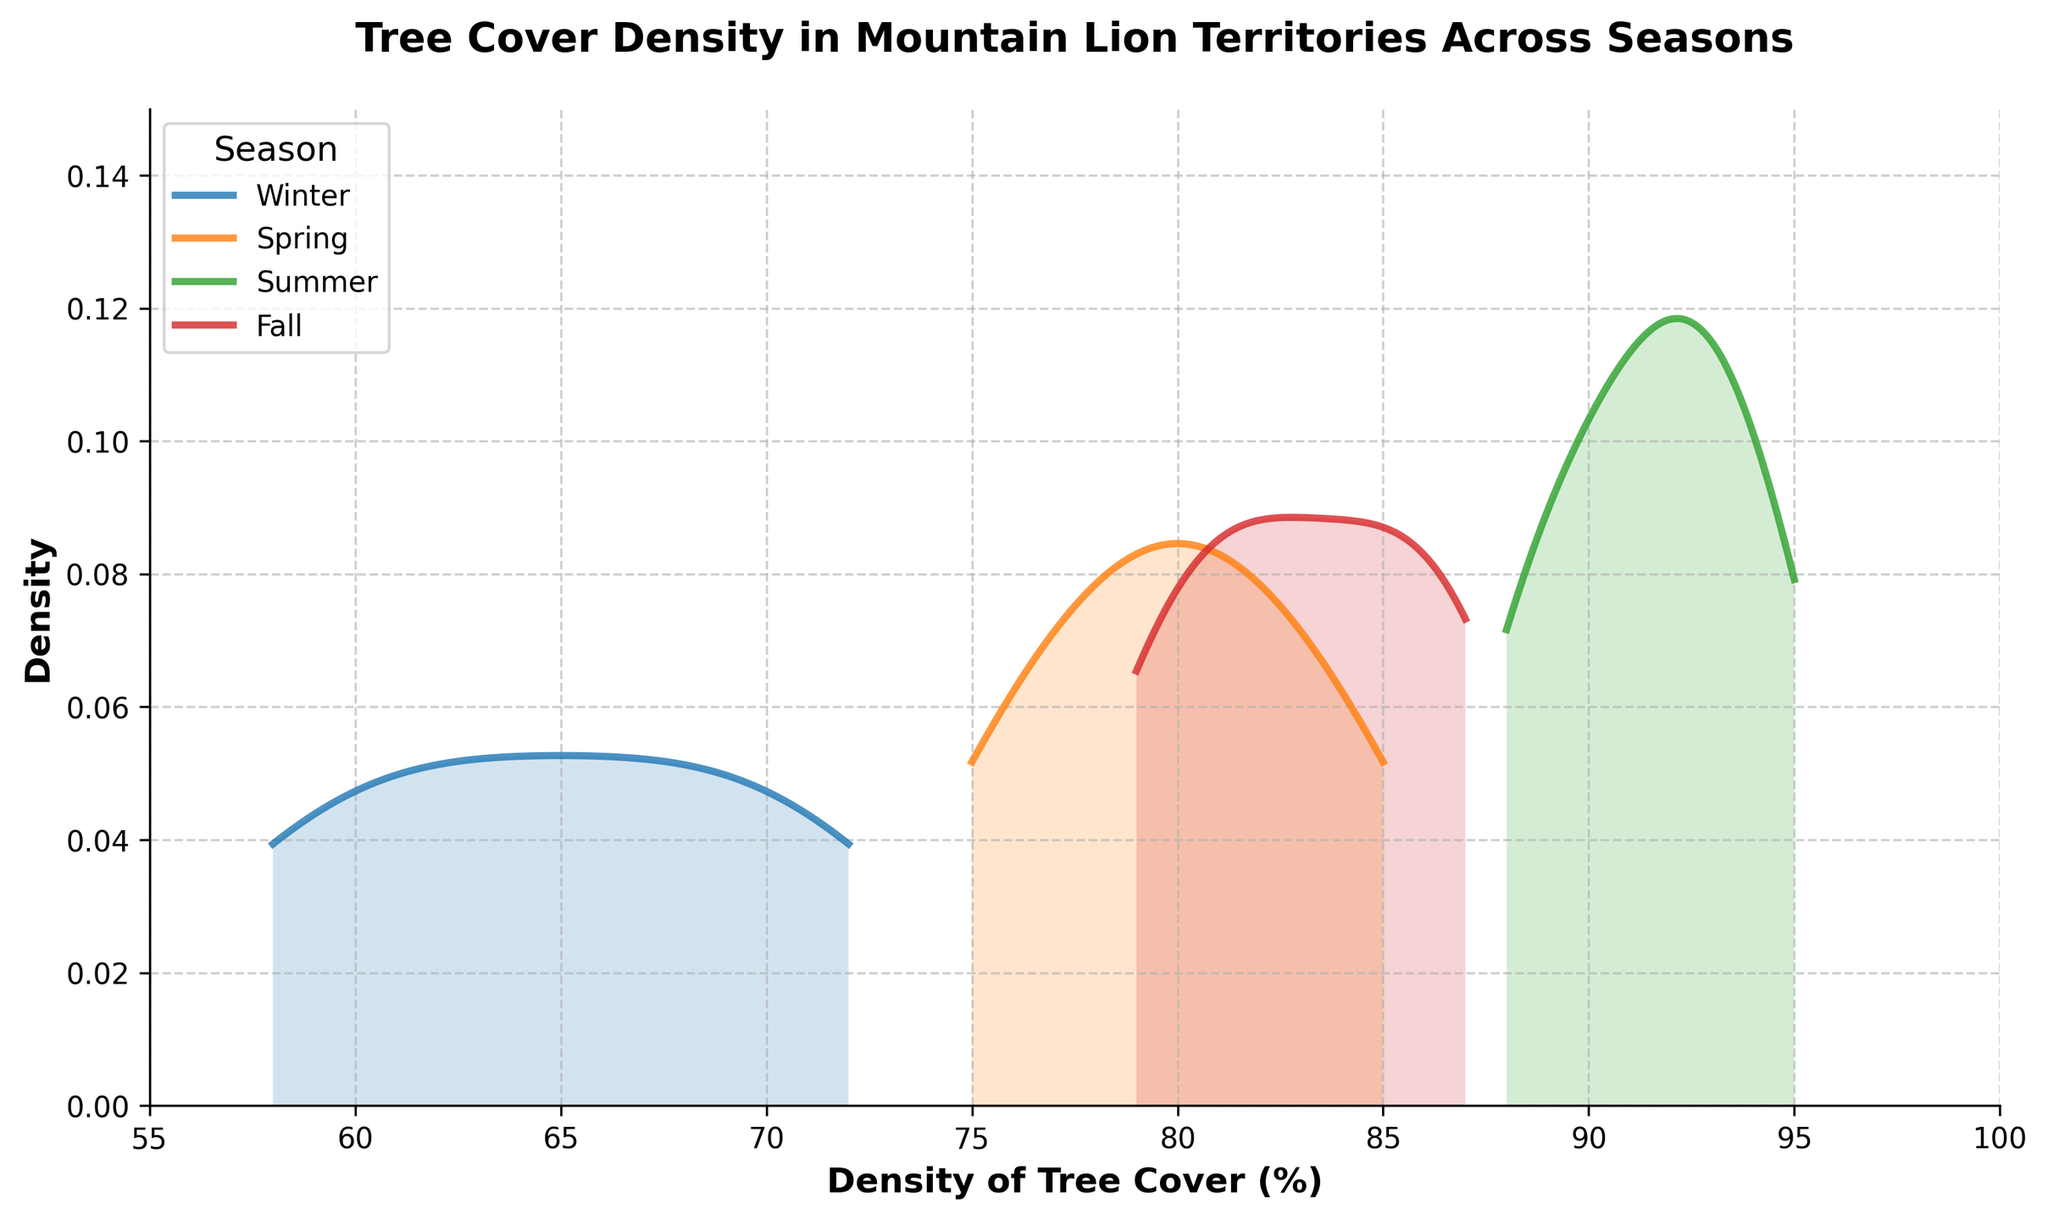What is the title of the density plot? The title of the plot is located at the top, and reads 'Tree Cover Density in Mountain Lion Territories Across Seasons'.
Answer: Tree Cover Density in Mountain Lion Territories Across Seasons What are the x-axis and y-axis labels? The x-axis label is 'Density of Tree Cover (%)' and the y-axis label is 'Density', as seen directly below and beside the respective axes.
Answer: Density of Tree Cover (%) and Density Which season has the highest peak density value? The highest peak on the density plot represents the season with the highest density. By examining the y-values, we see that Summer has the highest peak.
Answer: Summer What is the approximate range of tree cover density during Fall? By looking at the x-axis values corresponding to the Fall density curve, Fall ranges from about 79% to 87% tree cover density.
Answer: 79% to 87% Which season shows the widest spread in tree cover density? The spread is the range of values along the x-axis, and Summer's density curve shows the widest spread from about 88% to 95%.
Answer: Summer In which season does the density plot show the smallest variation in tree cover? The smallest variation would be the narrowest spread along the x-axis. Winter's density plot shows the smallest spread, roughly between 58% and 72%.
Answer: Winter How does the tree cover density in Spring compare to that in Fall? To compare, we observe that Spring's tree cover density ranges from about 75% to 85%, while Fall's ranges from about 79% to 87%. Both have similar ranges but Fall’s upper limit is slightly higher.
Answer: Fall has a slightly higher upper limit Which two seasons have overlapping ranges of tree cover density values? By observing the extent of the density curves on the x-axis, Spring and Fall both show ranges that overlap between 79% and 85%.
Answer: Spring and Fall What is the lowest tree cover density percentage observed across all seasons? The lowest value on the x-axis where any density curve starts is the minimum observed value. This occurs in Winter at approximately 58%.
Answer: 58% Describe the overall trend in tree cover density from Winter to Summer. Noticing how the density peaks move rightward, Winter has lower densities, Spring and Fall have moderate levels, and Summer has the highest densities.
Answer: Increasing from Winter to Summer 